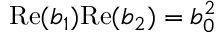Convert formula to latex. <formula><loc_0><loc_0><loc_500><loc_500>R e ( b _ { 1 } ) R e ( b _ { 2 } ) = b _ { 0 } ^ { 2 }</formula> 